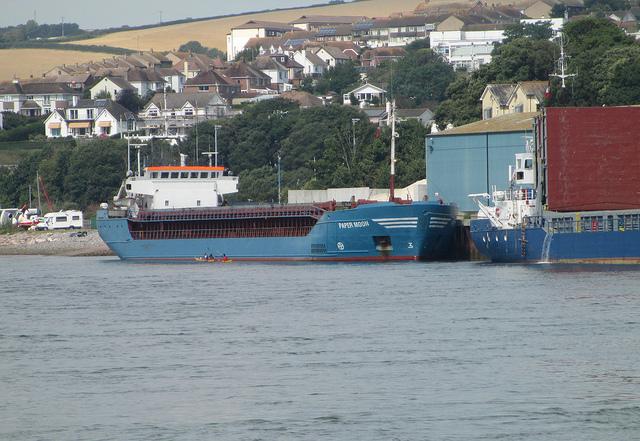Is there a small boat?
Keep it brief. No. Are these sailboats?
Quick response, please. No. Is the water cold?
Be succinct. Yes. 